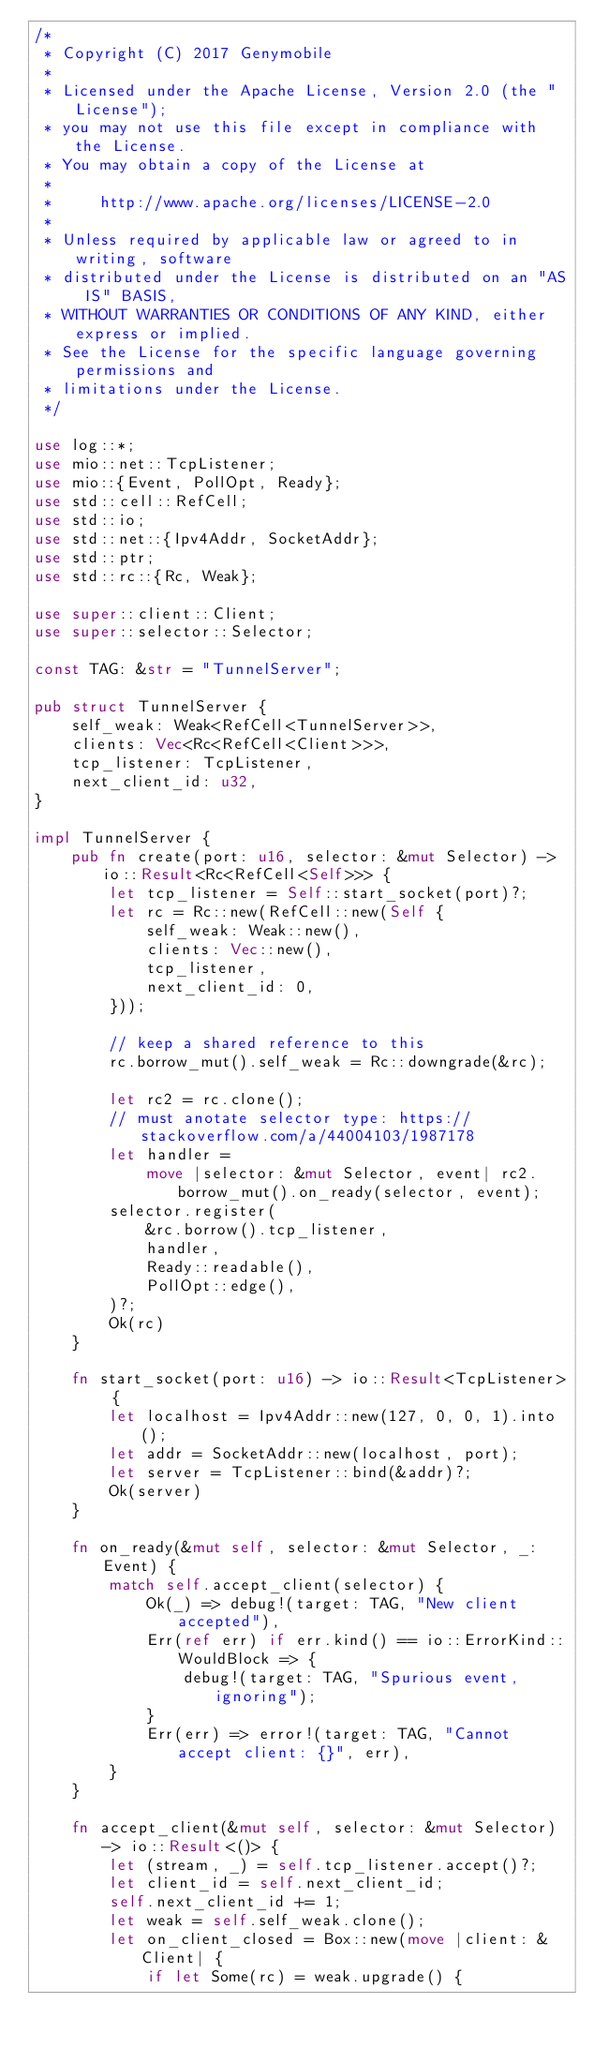Convert code to text. <code><loc_0><loc_0><loc_500><loc_500><_Rust_>/*
 * Copyright (C) 2017 Genymobile
 *
 * Licensed under the Apache License, Version 2.0 (the "License");
 * you may not use this file except in compliance with the License.
 * You may obtain a copy of the License at
 *
 *     http://www.apache.org/licenses/LICENSE-2.0
 *
 * Unless required by applicable law or agreed to in writing, software
 * distributed under the License is distributed on an "AS IS" BASIS,
 * WITHOUT WARRANTIES OR CONDITIONS OF ANY KIND, either express or implied.
 * See the License for the specific language governing permissions and
 * limitations under the License.
 */

use log::*;
use mio::net::TcpListener;
use mio::{Event, PollOpt, Ready};
use std::cell::RefCell;
use std::io;
use std::net::{Ipv4Addr, SocketAddr};
use std::ptr;
use std::rc::{Rc, Weak};

use super::client::Client;
use super::selector::Selector;

const TAG: &str = "TunnelServer";

pub struct TunnelServer {
    self_weak: Weak<RefCell<TunnelServer>>,
    clients: Vec<Rc<RefCell<Client>>>,
    tcp_listener: TcpListener,
    next_client_id: u32,
}

impl TunnelServer {
    pub fn create(port: u16, selector: &mut Selector) -> io::Result<Rc<RefCell<Self>>> {
        let tcp_listener = Self::start_socket(port)?;
        let rc = Rc::new(RefCell::new(Self {
            self_weak: Weak::new(),
            clients: Vec::new(),
            tcp_listener,
            next_client_id: 0,
        }));

        // keep a shared reference to this
        rc.borrow_mut().self_weak = Rc::downgrade(&rc);

        let rc2 = rc.clone();
        // must anotate selector type: https://stackoverflow.com/a/44004103/1987178
        let handler =
            move |selector: &mut Selector, event| rc2.borrow_mut().on_ready(selector, event);
        selector.register(
            &rc.borrow().tcp_listener,
            handler,
            Ready::readable(),
            PollOpt::edge(),
        )?;
        Ok(rc)
    }

    fn start_socket(port: u16) -> io::Result<TcpListener> {
        let localhost = Ipv4Addr::new(127, 0, 0, 1).into();
        let addr = SocketAddr::new(localhost, port);
        let server = TcpListener::bind(&addr)?;
        Ok(server)
    }

    fn on_ready(&mut self, selector: &mut Selector, _: Event) {
        match self.accept_client(selector) {
            Ok(_) => debug!(target: TAG, "New client accepted"),
            Err(ref err) if err.kind() == io::ErrorKind::WouldBlock => {
                debug!(target: TAG, "Spurious event, ignoring");
            }
            Err(err) => error!(target: TAG, "Cannot accept client: {}", err),
        }
    }

    fn accept_client(&mut self, selector: &mut Selector) -> io::Result<()> {
        let (stream, _) = self.tcp_listener.accept()?;
        let client_id = self.next_client_id;
        self.next_client_id += 1;
        let weak = self.self_weak.clone();
        let on_client_closed = Box::new(move |client: &Client| {
            if let Some(rc) = weak.upgrade() {</code> 